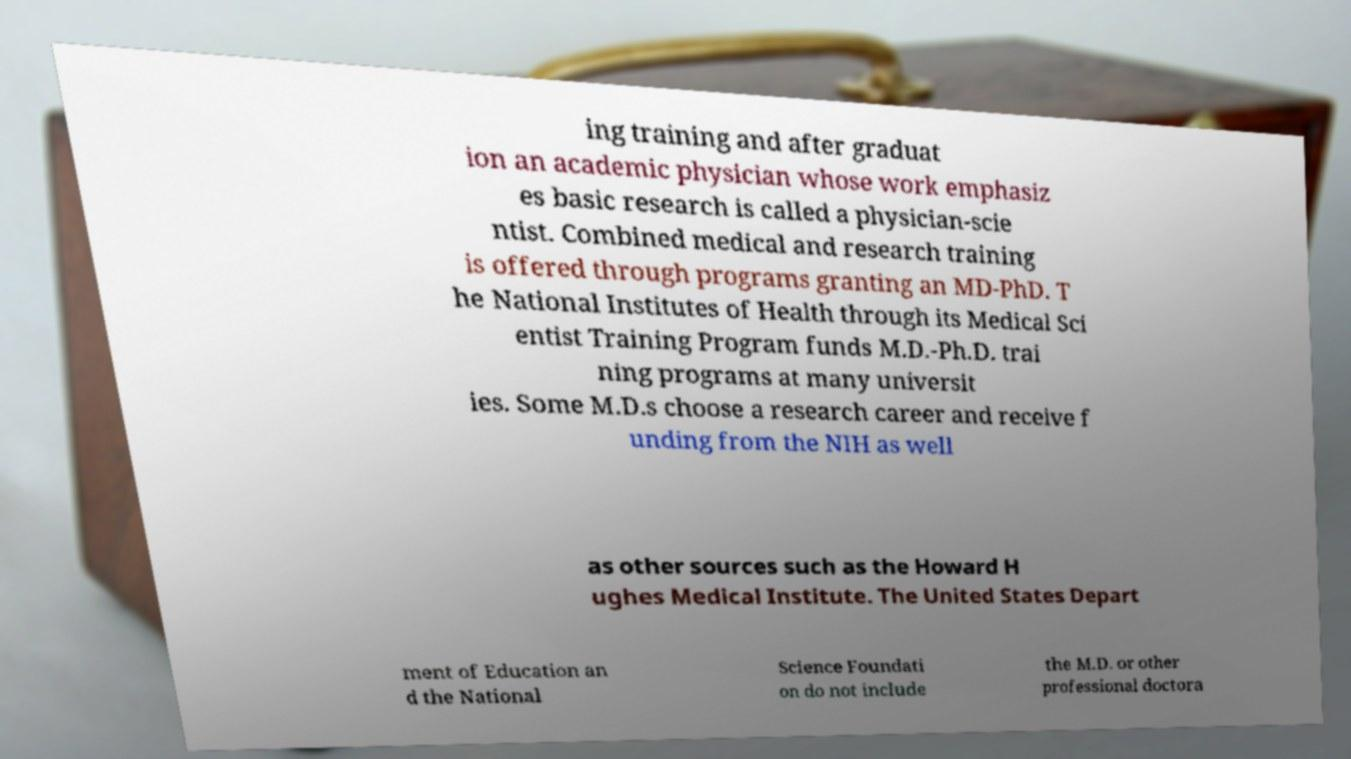For documentation purposes, I need the text within this image transcribed. Could you provide that? ing training and after graduat ion an academic physician whose work emphasiz es basic research is called a physician-scie ntist. Combined medical and research training is offered through programs granting an MD-PhD. T he National Institutes of Health through its Medical Sci entist Training Program funds M.D.-Ph.D. trai ning programs at many universit ies. Some M.D.s choose a research career and receive f unding from the NIH as well as other sources such as the Howard H ughes Medical Institute. The United States Depart ment of Education an d the National Science Foundati on do not include the M.D. or other professional doctora 